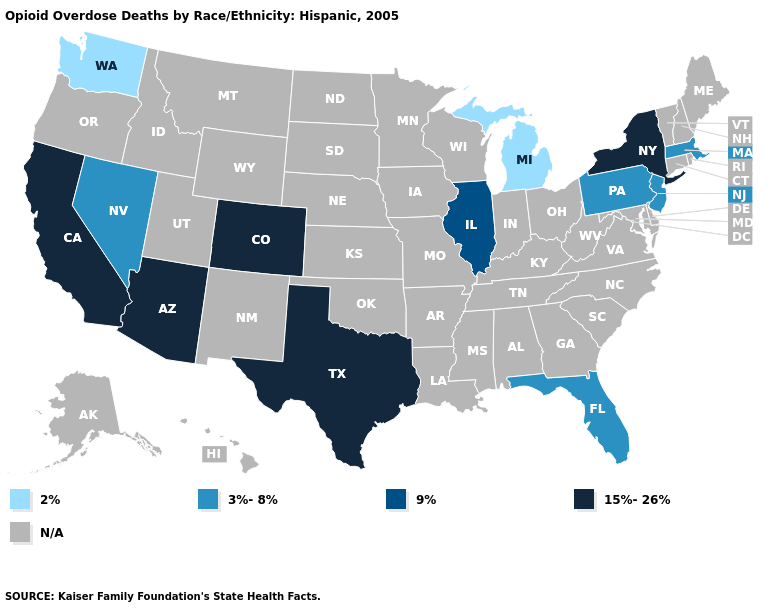Among the states that border New Jersey , which have the highest value?
Give a very brief answer. New York. Name the states that have a value in the range N/A?
Quick response, please. Alabama, Alaska, Arkansas, Connecticut, Delaware, Georgia, Hawaii, Idaho, Indiana, Iowa, Kansas, Kentucky, Louisiana, Maine, Maryland, Minnesota, Mississippi, Missouri, Montana, Nebraska, New Hampshire, New Mexico, North Carolina, North Dakota, Ohio, Oklahoma, Oregon, Rhode Island, South Carolina, South Dakota, Tennessee, Utah, Vermont, Virginia, West Virginia, Wisconsin, Wyoming. Name the states that have a value in the range 15%-26%?
Keep it brief. Arizona, California, Colorado, New York, Texas. Among the states that border Kentucky , which have the highest value?
Write a very short answer. Illinois. What is the highest value in the USA?
Concise answer only. 15%-26%. Is the legend a continuous bar?
Give a very brief answer. No. Does Michigan have the lowest value in the USA?
Concise answer only. Yes. What is the value of Hawaii?
Quick response, please. N/A. What is the value of Kansas?
Write a very short answer. N/A. What is the lowest value in states that border Ohio?
Write a very short answer. 2%. Name the states that have a value in the range 15%-26%?
Short answer required. Arizona, California, Colorado, New York, Texas. What is the lowest value in the MidWest?
Write a very short answer. 2%. Does Illinois have the highest value in the MidWest?
Quick response, please. Yes. 